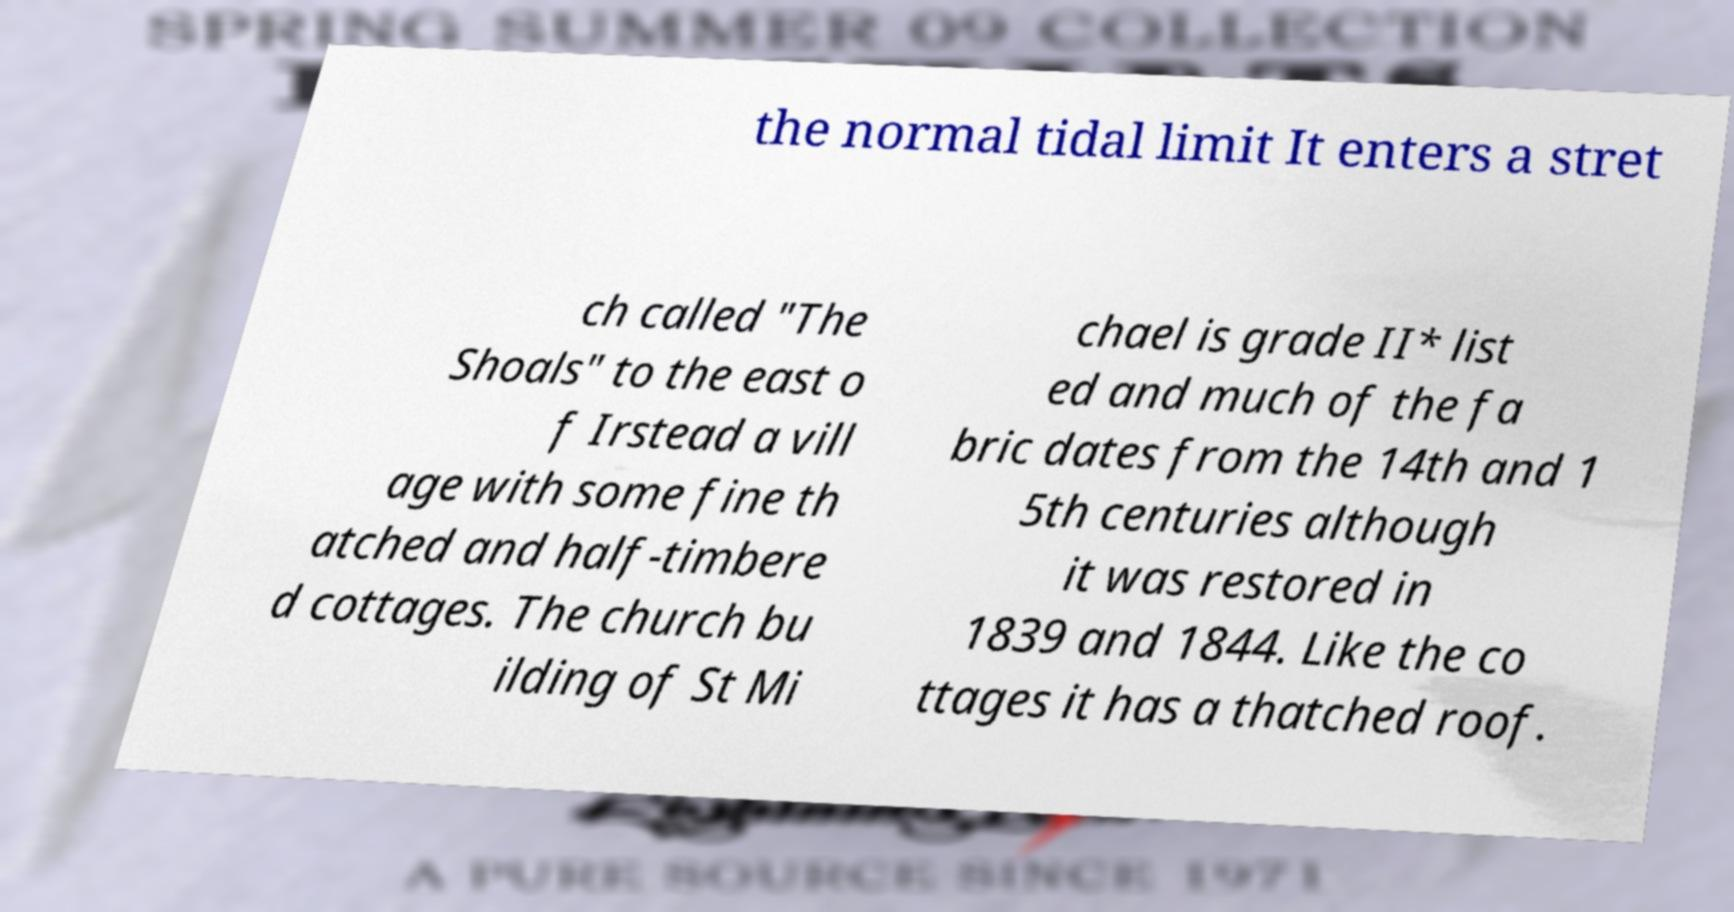Can you accurately transcribe the text from the provided image for me? the normal tidal limit It enters a stret ch called "The Shoals" to the east o f Irstead a vill age with some fine th atched and half-timbere d cottages. The church bu ilding of St Mi chael is grade II* list ed and much of the fa bric dates from the 14th and 1 5th centuries although it was restored in 1839 and 1844. Like the co ttages it has a thatched roof. 